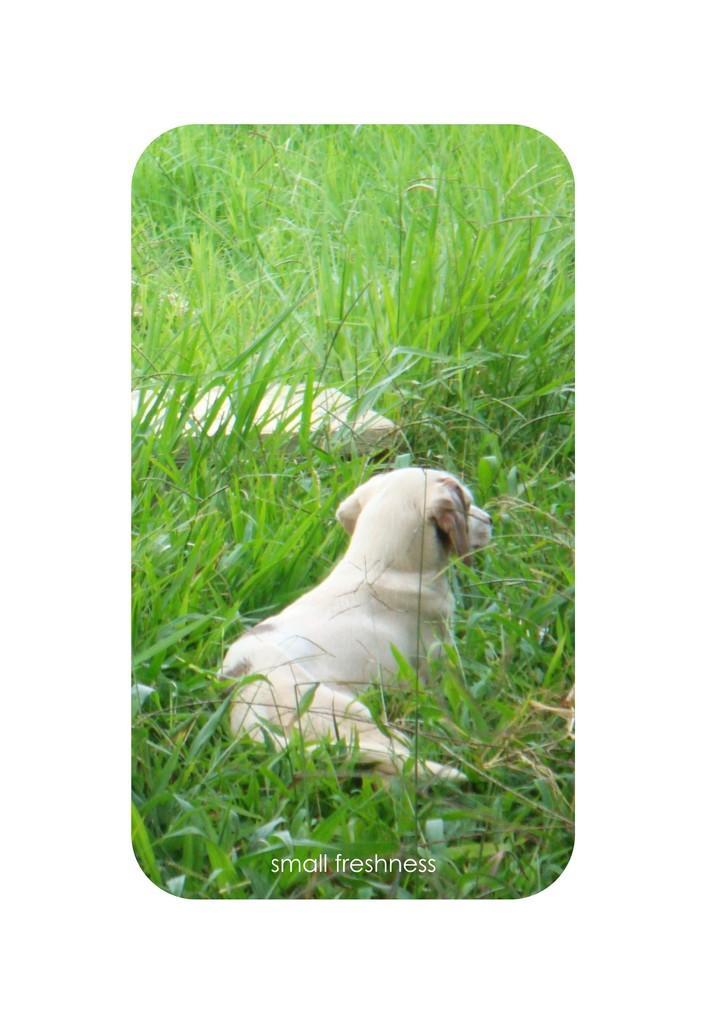Describe this image in one or two sentences. In this image there is a puppy sitting in the grass. 